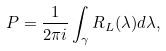Convert formula to latex. <formula><loc_0><loc_0><loc_500><loc_500>P = \frac { 1 } { 2 \pi i } \int _ { \gamma } R _ { L } ( \lambda ) d \lambda ,</formula> 